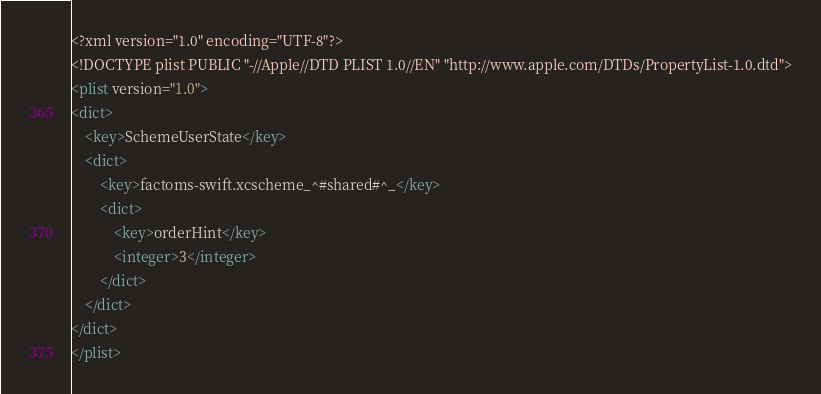Convert code to text. <code><loc_0><loc_0><loc_500><loc_500><_XML_><?xml version="1.0" encoding="UTF-8"?>
<!DOCTYPE plist PUBLIC "-//Apple//DTD PLIST 1.0//EN" "http://www.apple.com/DTDs/PropertyList-1.0.dtd">
<plist version="1.0">
<dict>
	<key>SchemeUserState</key>
	<dict>
		<key>factoms-swift.xcscheme_^#shared#^_</key>
		<dict>
			<key>orderHint</key>
			<integer>3</integer>
		</dict>
	</dict>
</dict>
</plist>
</code> 